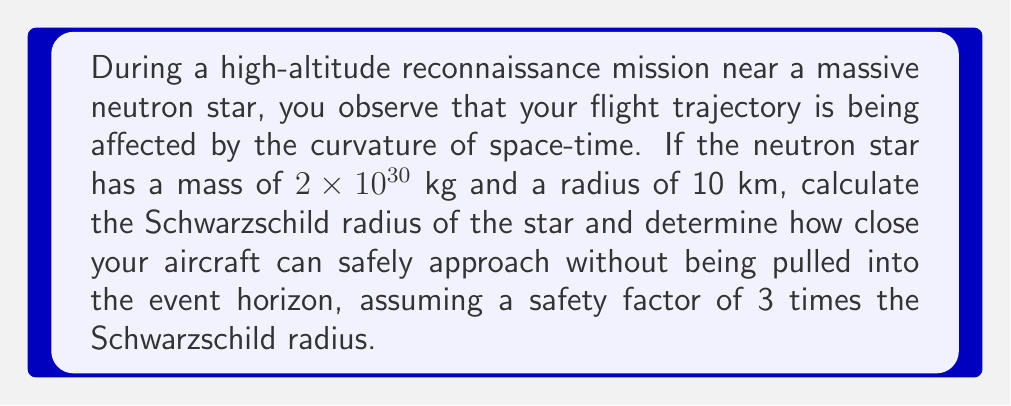Show me your answer to this math problem. 1. The Schwarzschild radius ($r_s$) is given by the equation:

   $$r_s = \frac{2GM}{c^2}$$

   Where:
   $G$ is the gravitational constant ($6.674 \times 10^{-11} \text{ m}^3 \text{ kg}^{-1} \text{ s}^{-2}$)
   $M$ is the mass of the neutron star
   $c$ is the speed of light ($2.998 \times 10^8 \text{ m/s}$)

2. Substitute the values:

   $$r_s = \frac{2 \times (6.674 \times 10^{-11}) \times (2 \times 10^{30})}{(2.998 \times 10^8)^2}$$

3. Calculate:

   $$r_s \approx 2.95 \text{ km}$$

4. The safe distance is 3 times the Schwarzschild radius:

   $$\text{Safe distance} = 3 \times r_s = 3 \times 2.95 \text{ km} = 8.85 \text{ km}$$

5. Since the neutron star's radius (10 km) is larger than the safe distance (8.85 km), the aircraft should not approach closer than the star's surface.
Answer: 10 km (neutron star's surface) 